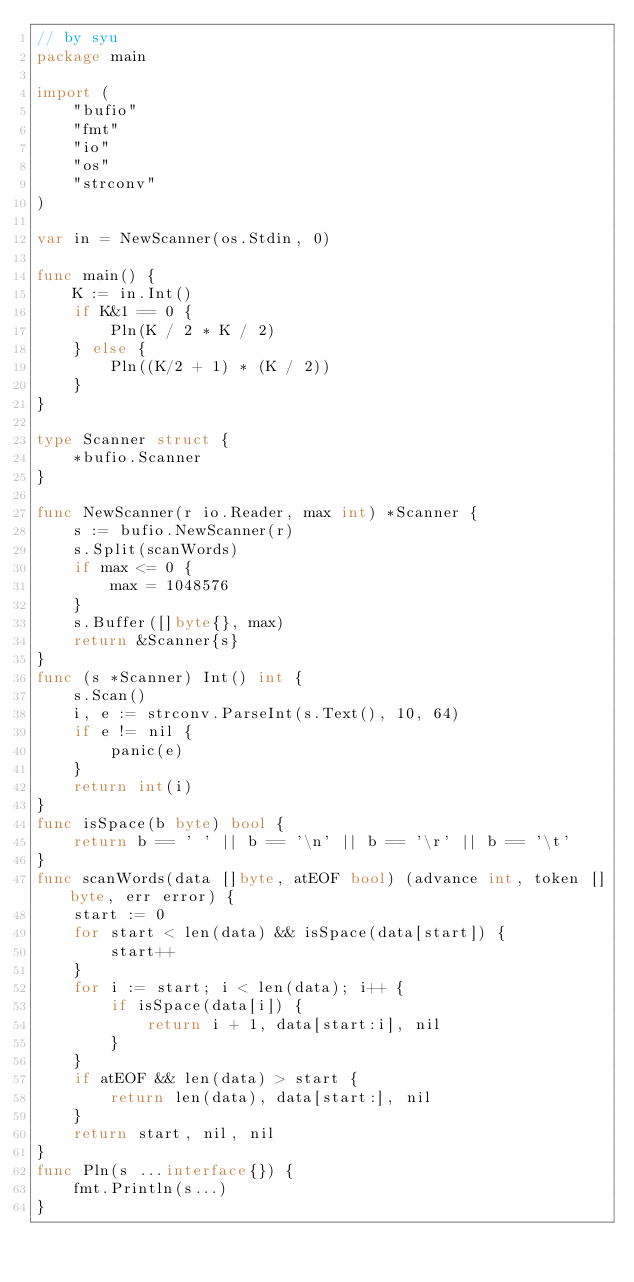<code> <loc_0><loc_0><loc_500><loc_500><_Go_>// by syu
package main

import (
	"bufio"
	"fmt"
	"io"
	"os"
	"strconv"
)

var in = NewScanner(os.Stdin, 0)

func main() {
	K := in.Int()
	if K&1 == 0 {
		Pln(K / 2 * K / 2)
	} else {
		Pln((K/2 + 1) * (K / 2))
	}
}

type Scanner struct {
	*bufio.Scanner
}

func NewScanner(r io.Reader, max int) *Scanner {
	s := bufio.NewScanner(r)
	s.Split(scanWords)
	if max <= 0 {
		max = 1048576
	}
	s.Buffer([]byte{}, max)
	return &Scanner{s}
}
func (s *Scanner) Int() int {
	s.Scan()
	i, e := strconv.ParseInt(s.Text(), 10, 64)
	if e != nil {
		panic(e)
	}
	return int(i)
}
func isSpace(b byte) bool {
	return b == ' ' || b == '\n' || b == '\r' || b == '\t'
}
func scanWords(data []byte, atEOF bool) (advance int, token []byte, err error) {
	start := 0
	for start < len(data) && isSpace(data[start]) {
		start++
	}
	for i := start; i < len(data); i++ {
		if isSpace(data[i]) {
			return i + 1, data[start:i], nil
		}
	}
	if atEOF && len(data) > start {
		return len(data), data[start:], nil
	}
	return start, nil, nil
}
func Pln(s ...interface{}) {
	fmt.Println(s...)
}
</code> 